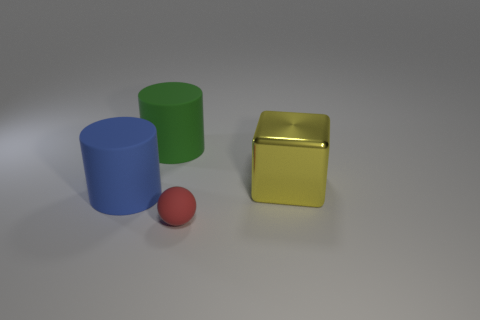Is there anything else that has the same material as the large yellow cube?
Provide a succinct answer. No. There is a rubber object that is to the right of the large blue rubber thing and behind the small red rubber thing; what is its color?
Provide a short and direct response. Green. What number of other objects are there of the same color as the big shiny thing?
Provide a short and direct response. 0. What is the color of the big cylinder right of the large blue object?
Provide a succinct answer. Green. Is there a green matte thing that has the same size as the yellow shiny thing?
Ensure brevity in your answer.  Yes. There is a green object that is the same size as the blue matte object; what is it made of?
Give a very brief answer. Rubber. How many objects are objects behind the tiny sphere or things on the right side of the sphere?
Give a very brief answer. 3. Are there any green matte things that have the same shape as the large blue object?
Ensure brevity in your answer.  Yes. What number of metallic objects are either tiny spheres or cylinders?
Ensure brevity in your answer.  0. There is a tiny rubber object; what shape is it?
Ensure brevity in your answer.  Sphere. 